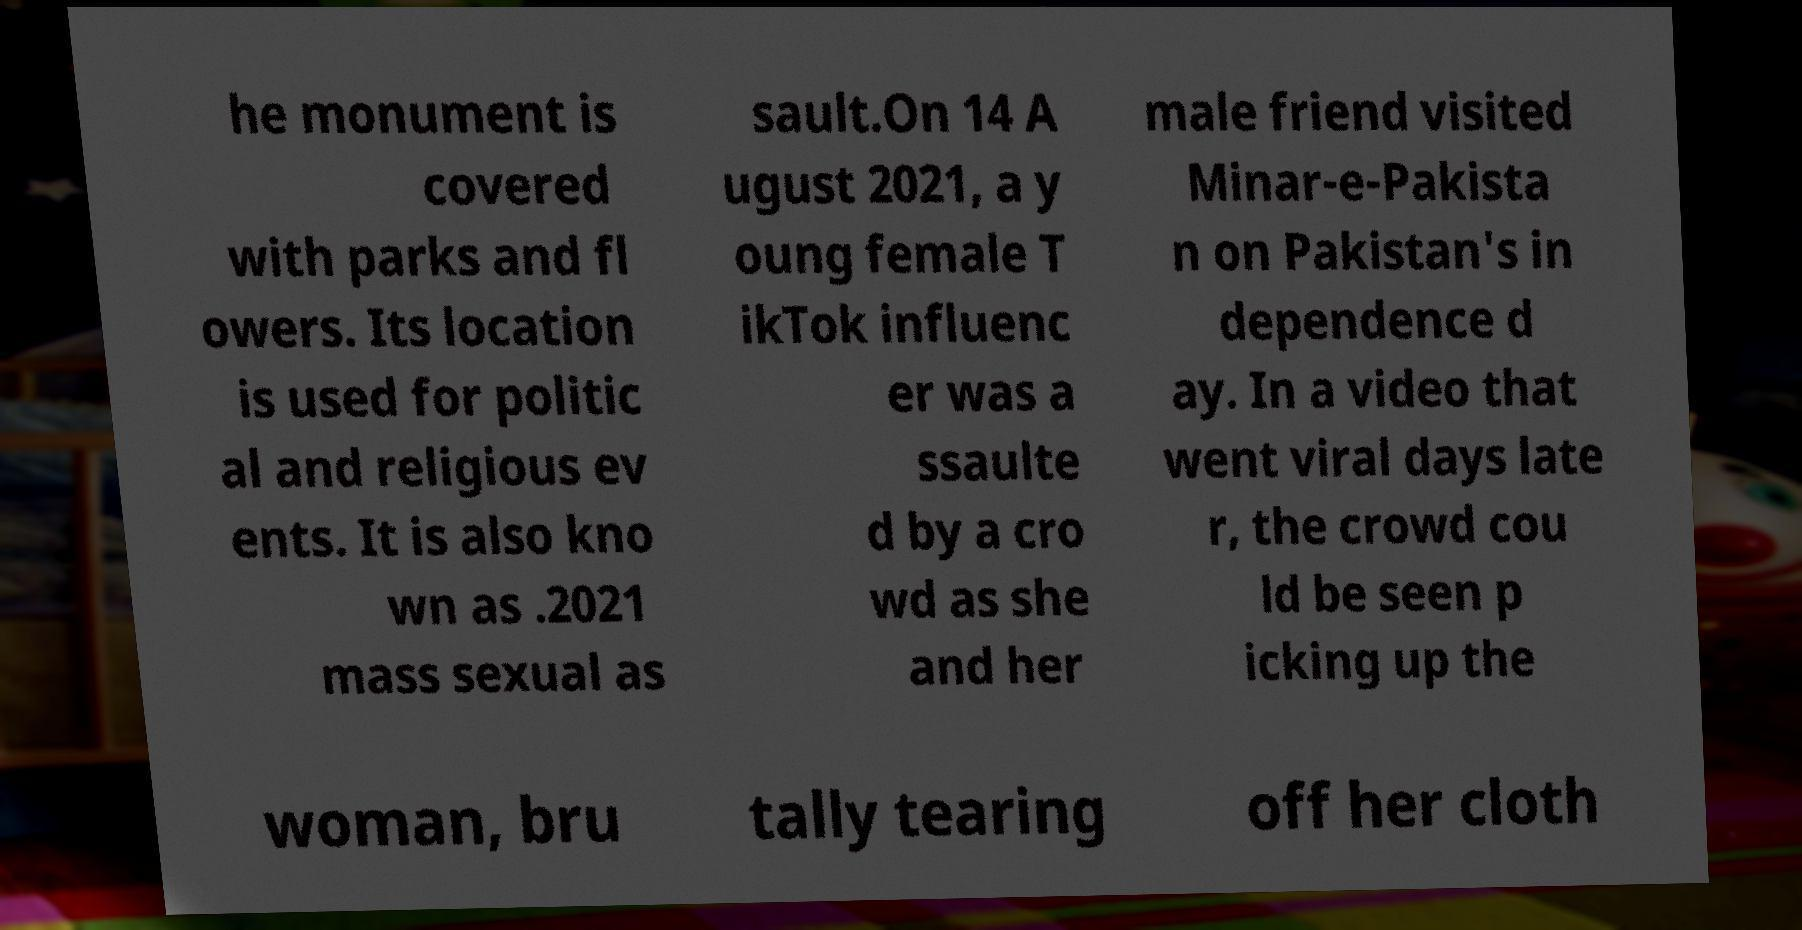Please identify and transcribe the text found in this image. he monument is covered with parks and fl owers. Its location is used for politic al and religious ev ents. It is also kno wn as .2021 mass sexual as sault.On 14 A ugust 2021, a y oung female T ikTok influenc er was a ssaulte d by a cro wd as she and her male friend visited Minar-e-Pakista n on Pakistan's in dependence d ay. In a video that went viral days late r, the crowd cou ld be seen p icking up the woman, bru tally tearing off her cloth 